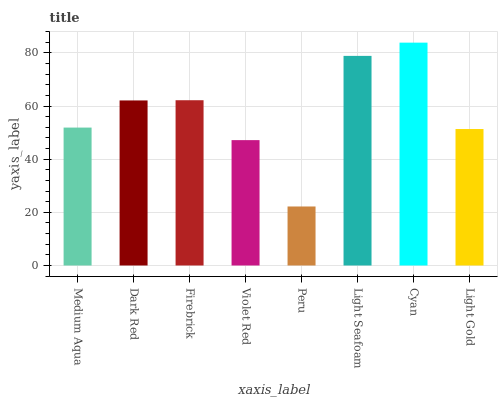Is Peru the minimum?
Answer yes or no. Yes. Is Cyan the maximum?
Answer yes or no. Yes. Is Dark Red the minimum?
Answer yes or no. No. Is Dark Red the maximum?
Answer yes or no. No. Is Dark Red greater than Medium Aqua?
Answer yes or no. Yes. Is Medium Aqua less than Dark Red?
Answer yes or no. Yes. Is Medium Aqua greater than Dark Red?
Answer yes or no. No. Is Dark Red less than Medium Aqua?
Answer yes or no. No. Is Dark Red the high median?
Answer yes or no. Yes. Is Medium Aqua the low median?
Answer yes or no. Yes. Is Medium Aqua the high median?
Answer yes or no. No. Is Dark Red the low median?
Answer yes or no. No. 